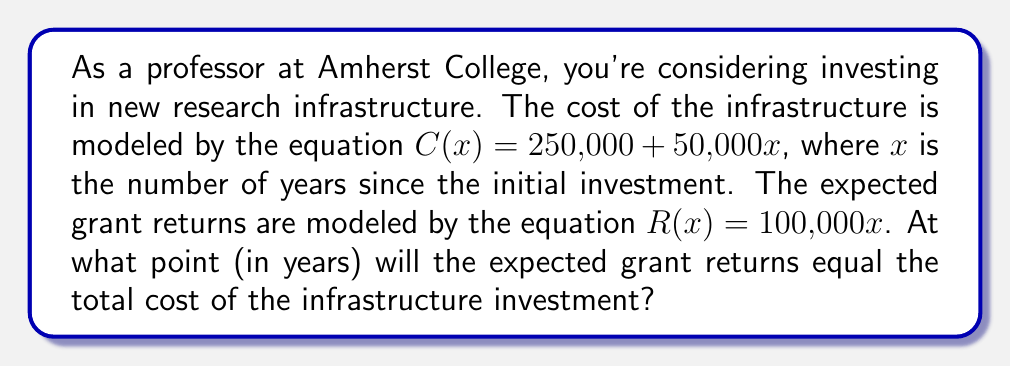Provide a solution to this math problem. To solve this problem, we need to find the break-even point where the cost equals the revenue. This can be done by setting up an equation and solving for $x$.

1) Set up the equation:
   $C(x) = R(x)$

2) Substitute the given functions:
   $250,000 + 50,000x = 100,000x$

3) Simplify:
   $250,000 = 100,000x - 50,000x$
   $250,000 = 50,000x$

4) Solve for $x$:
   $$x = \frac{250,000}{50,000} = 5$$

5) Check the solution:
   At $x = 5$ years:
   $C(5) = 250,000 + 50,000(5) = 500,000$
   $R(5) = 100,000(5) = 500,000$

   Indeed, the cost and revenue are equal at 5 years.
Answer: The break-even point occurs at 5 years after the initial investment. 